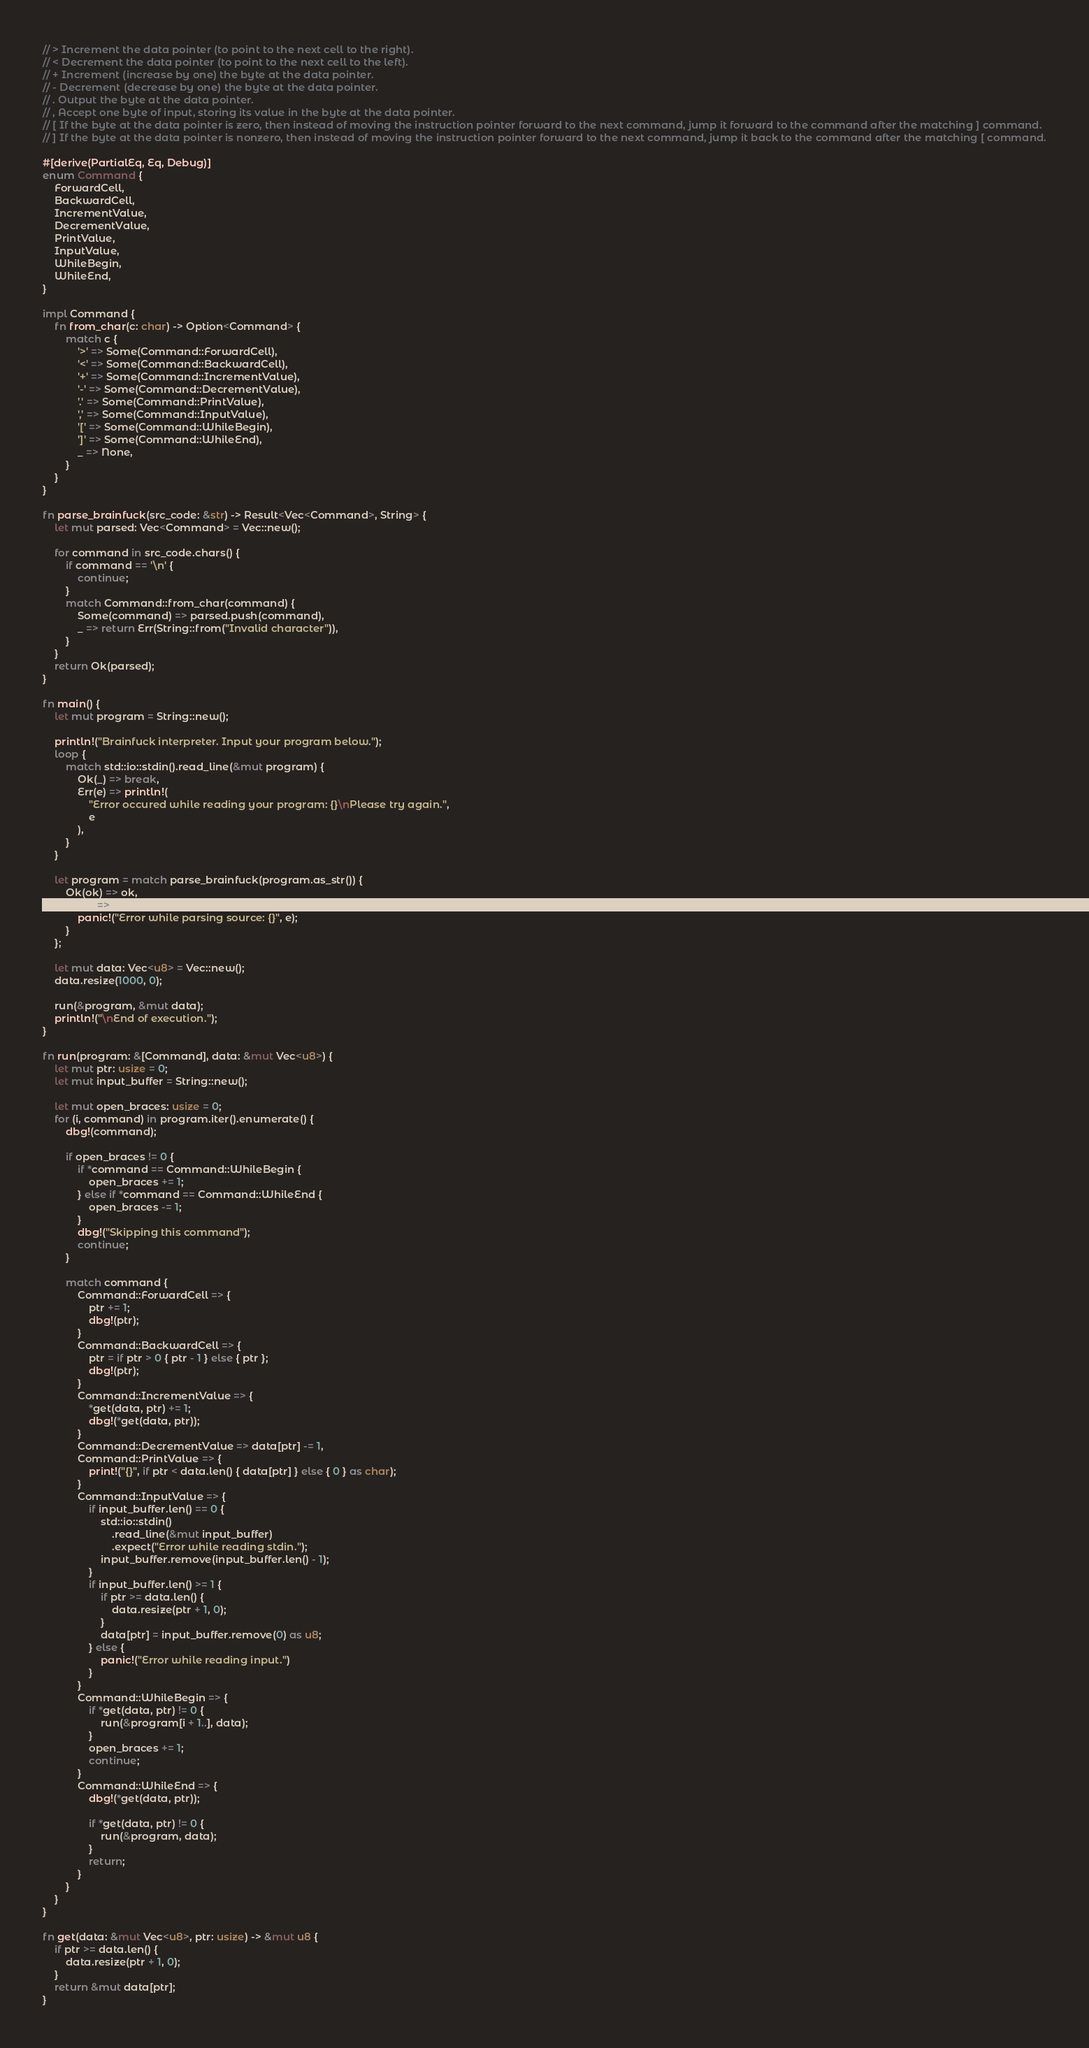Convert code to text. <code><loc_0><loc_0><loc_500><loc_500><_Rust_>// > Increment the data pointer (to point to the next cell to the right).
// < Decrement the data pointer (to point to the next cell to the left).
// + Increment (increase by one) the byte at the data pointer.
// - Decrement (decrease by one) the byte at the data pointer.
// . Output the byte at the data pointer.
// , Accept one byte of input, storing its value in the byte at the data pointer.
// [ If the byte at the data pointer is zero, then instead of moving the instruction pointer forward to the next command, jump it forward to the command after the matching ] command.
// ] If the byte at the data pointer is nonzero, then instead of moving the instruction pointer forward to the next command, jump it back to the command after the matching [ command.

#[derive(PartialEq, Eq, Debug)]
enum Command {
    ForwardCell,
    BackwardCell,
    IncrementValue,
    DecrementValue,
    PrintValue,
    InputValue,
    WhileBegin,
    WhileEnd,
}

impl Command {
    fn from_char(c: char) -> Option<Command> {
        match c {
            '>' => Some(Command::ForwardCell),
            '<' => Some(Command::BackwardCell),
            '+' => Some(Command::IncrementValue),
            '-' => Some(Command::DecrementValue),
            '.' => Some(Command::PrintValue),
            ',' => Some(Command::InputValue),
            '[' => Some(Command::WhileBegin),
            ']' => Some(Command::WhileEnd),
            _ => None,
        }
    }
}

fn parse_brainfuck(src_code: &str) -> Result<Vec<Command>, String> {
    let mut parsed: Vec<Command> = Vec::new();

    for command in src_code.chars() {
        if command == '\n' {
            continue;
        }
        match Command::from_char(command) {
            Some(command) => parsed.push(command),
            _ => return Err(String::from("Invalid character")),
        }
    }
    return Ok(parsed);
}

fn main() {
    let mut program = String::new();

    println!("Brainfuck interpreter. Input your program below.");
    loop {
        match std::io::stdin().read_line(&mut program) {
            Ok(_) => break,
            Err(e) => println!(
                "Error occured while reading your program: {}\nPlease try again.",
                e
            ),
        }
    }

    let program = match parse_brainfuck(program.as_str()) {
        Ok(ok) => ok,
        Err(e) => {
            panic!("Error while parsing source: {}", e);
        }
    };

    let mut data: Vec<u8> = Vec::new();
    data.resize(1000, 0);

    run(&program, &mut data);
    println!("\nEnd of execution.");
}

fn run(program: &[Command], data: &mut Vec<u8>) {
    let mut ptr: usize = 0;
    let mut input_buffer = String::new();

    let mut open_braces: usize = 0;
    for (i, command) in program.iter().enumerate() {
        dbg!(command);

        if open_braces != 0 {
            if *command == Command::WhileBegin {
                open_braces += 1;
            } else if *command == Command::WhileEnd {
                open_braces -= 1;
            }
            dbg!("Skipping this command");
            continue;
        }

        match command {
            Command::ForwardCell => {
                ptr += 1;
                dbg!(ptr);
            }
            Command::BackwardCell => {
                ptr = if ptr > 0 { ptr - 1 } else { ptr };
                dbg!(ptr);
            }
            Command::IncrementValue => {
                *get(data, ptr) += 1;
                dbg!(*get(data, ptr));
            }
            Command::DecrementValue => data[ptr] -= 1,
            Command::PrintValue => {
                print!("{}", if ptr < data.len() { data[ptr] } else { 0 } as char);
            }
            Command::InputValue => {
                if input_buffer.len() == 0 {
                    std::io::stdin()
                        .read_line(&mut input_buffer)
                        .expect("Error while reading stdin.");
                    input_buffer.remove(input_buffer.len() - 1);
                }
                if input_buffer.len() >= 1 {
                    if ptr >= data.len() {
                        data.resize(ptr + 1, 0);
                    }
                    data[ptr] = input_buffer.remove(0) as u8;
                } else {
                    panic!("Error while reading input.")
                }
            }
            Command::WhileBegin => {
                if *get(data, ptr) != 0 {
                    run(&program[i + 1..], data);
                }
                open_braces += 1;
                continue;
            }
            Command::WhileEnd => {
                dbg!(*get(data, ptr));

                if *get(data, ptr) != 0 {
                    run(&program, data);
                }
                return;
            }
        }
    }
}

fn get(data: &mut Vec<u8>, ptr: usize) -> &mut u8 {
    if ptr >= data.len() {
        data.resize(ptr + 1, 0);
    }
    return &mut data[ptr];
}
</code> 